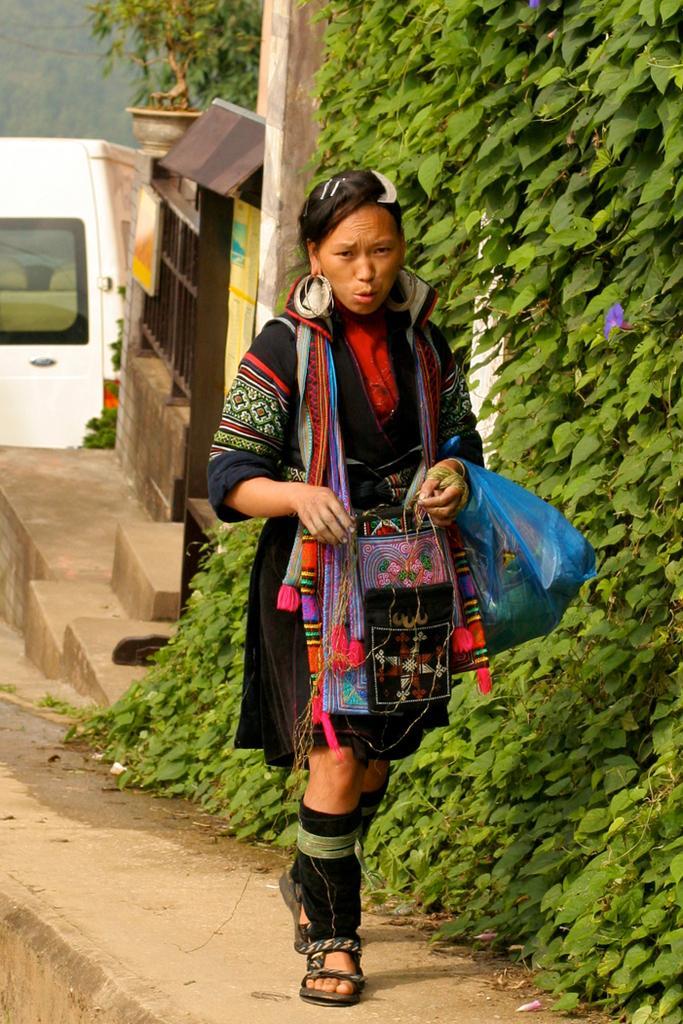Describe this image in one or two sentences. The women wearing black dress is walking and there are green trees beside her and there is a white a van behind her. 